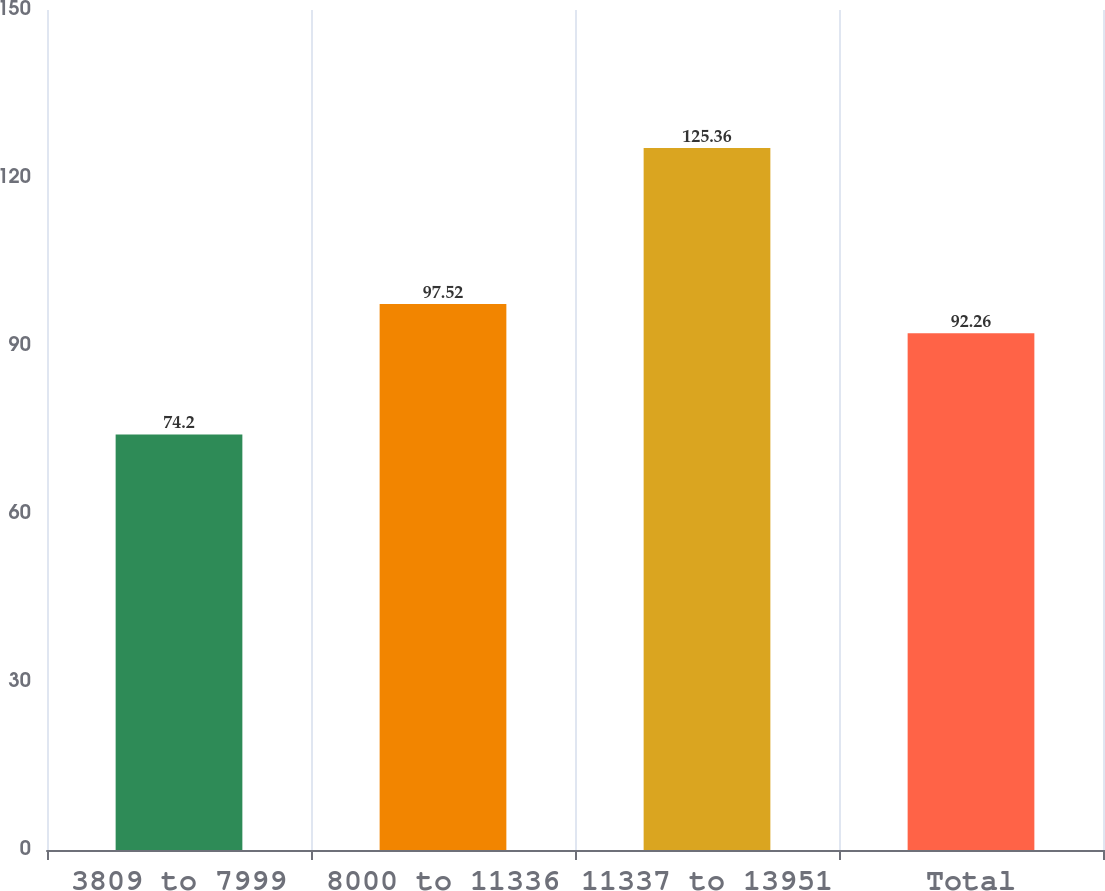<chart> <loc_0><loc_0><loc_500><loc_500><bar_chart><fcel>3809 to 7999<fcel>8000 to 11336<fcel>11337 to 13951<fcel>Total<nl><fcel>74.2<fcel>97.52<fcel>125.36<fcel>92.26<nl></chart> 